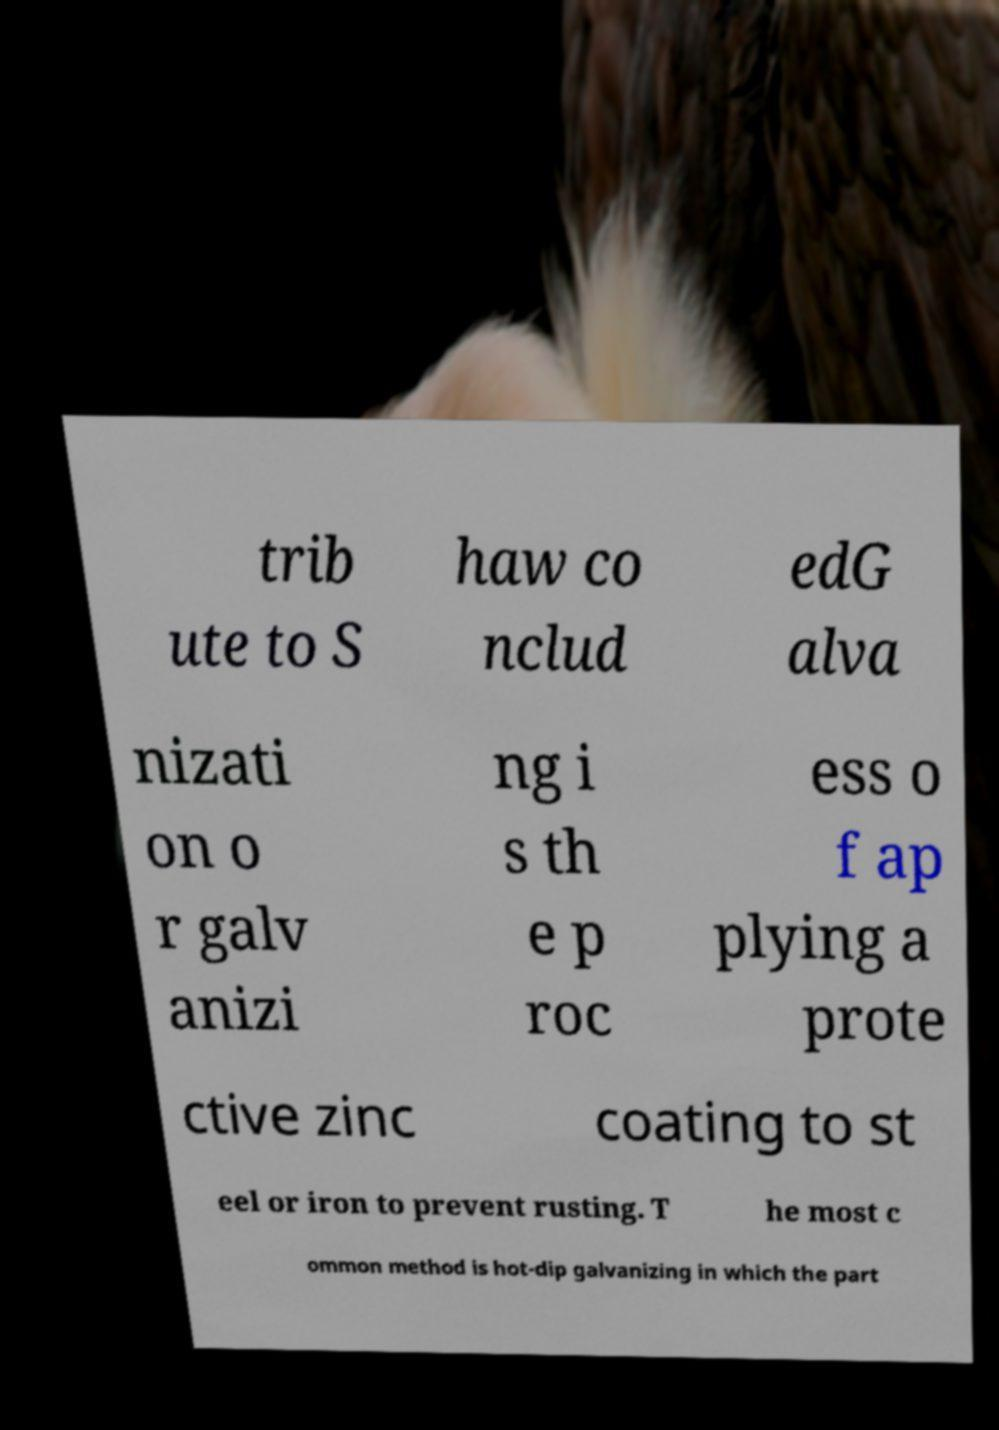Could you extract and type out the text from this image? trib ute to S haw co nclud edG alva nizati on o r galv anizi ng i s th e p roc ess o f ap plying a prote ctive zinc coating to st eel or iron to prevent rusting. T he most c ommon method is hot-dip galvanizing in which the part 